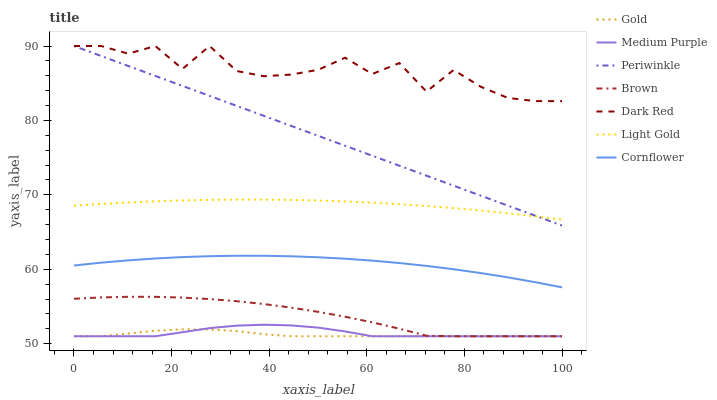Does Gold have the minimum area under the curve?
Answer yes or no. Yes. Does Dark Red have the maximum area under the curve?
Answer yes or no. Yes. Does Cornflower have the minimum area under the curve?
Answer yes or no. No. Does Cornflower have the maximum area under the curve?
Answer yes or no. No. Is Periwinkle the smoothest?
Answer yes or no. Yes. Is Dark Red the roughest?
Answer yes or no. Yes. Is Gold the smoothest?
Answer yes or no. No. Is Gold the roughest?
Answer yes or no. No. Does Cornflower have the lowest value?
Answer yes or no. No. Does Cornflower have the highest value?
Answer yes or no. No. Is Gold less than Periwinkle?
Answer yes or no. Yes. Is Dark Red greater than Gold?
Answer yes or no. Yes. Does Gold intersect Periwinkle?
Answer yes or no. No. 